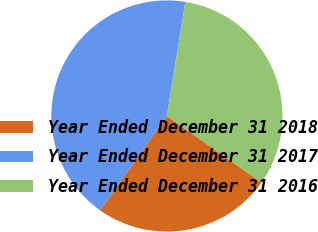Convert chart. <chart><loc_0><loc_0><loc_500><loc_500><pie_chart><fcel>Year Ended December 31 2018<fcel>Year Ended December 31 2017<fcel>Year Ended December 31 2016<nl><fcel>25.06%<fcel>42.73%<fcel>32.22%<nl></chart> 